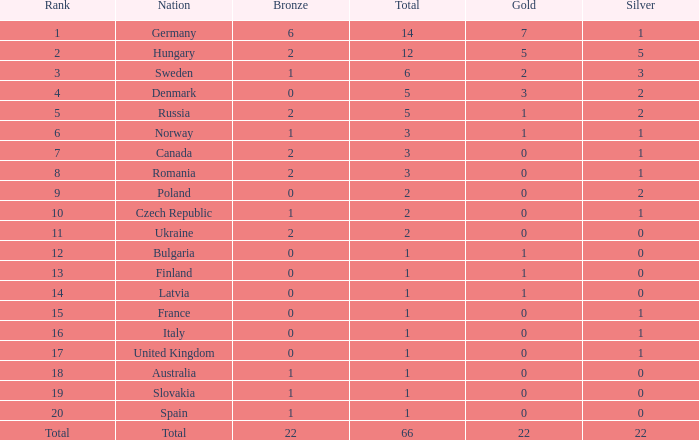What is the fewest number of silver medals won by Canada with fewer than 3 total medals? None. 